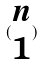<formula> <loc_0><loc_0><loc_500><loc_500>( \begin{matrix} n \\ 1 \end{matrix} )</formula> 